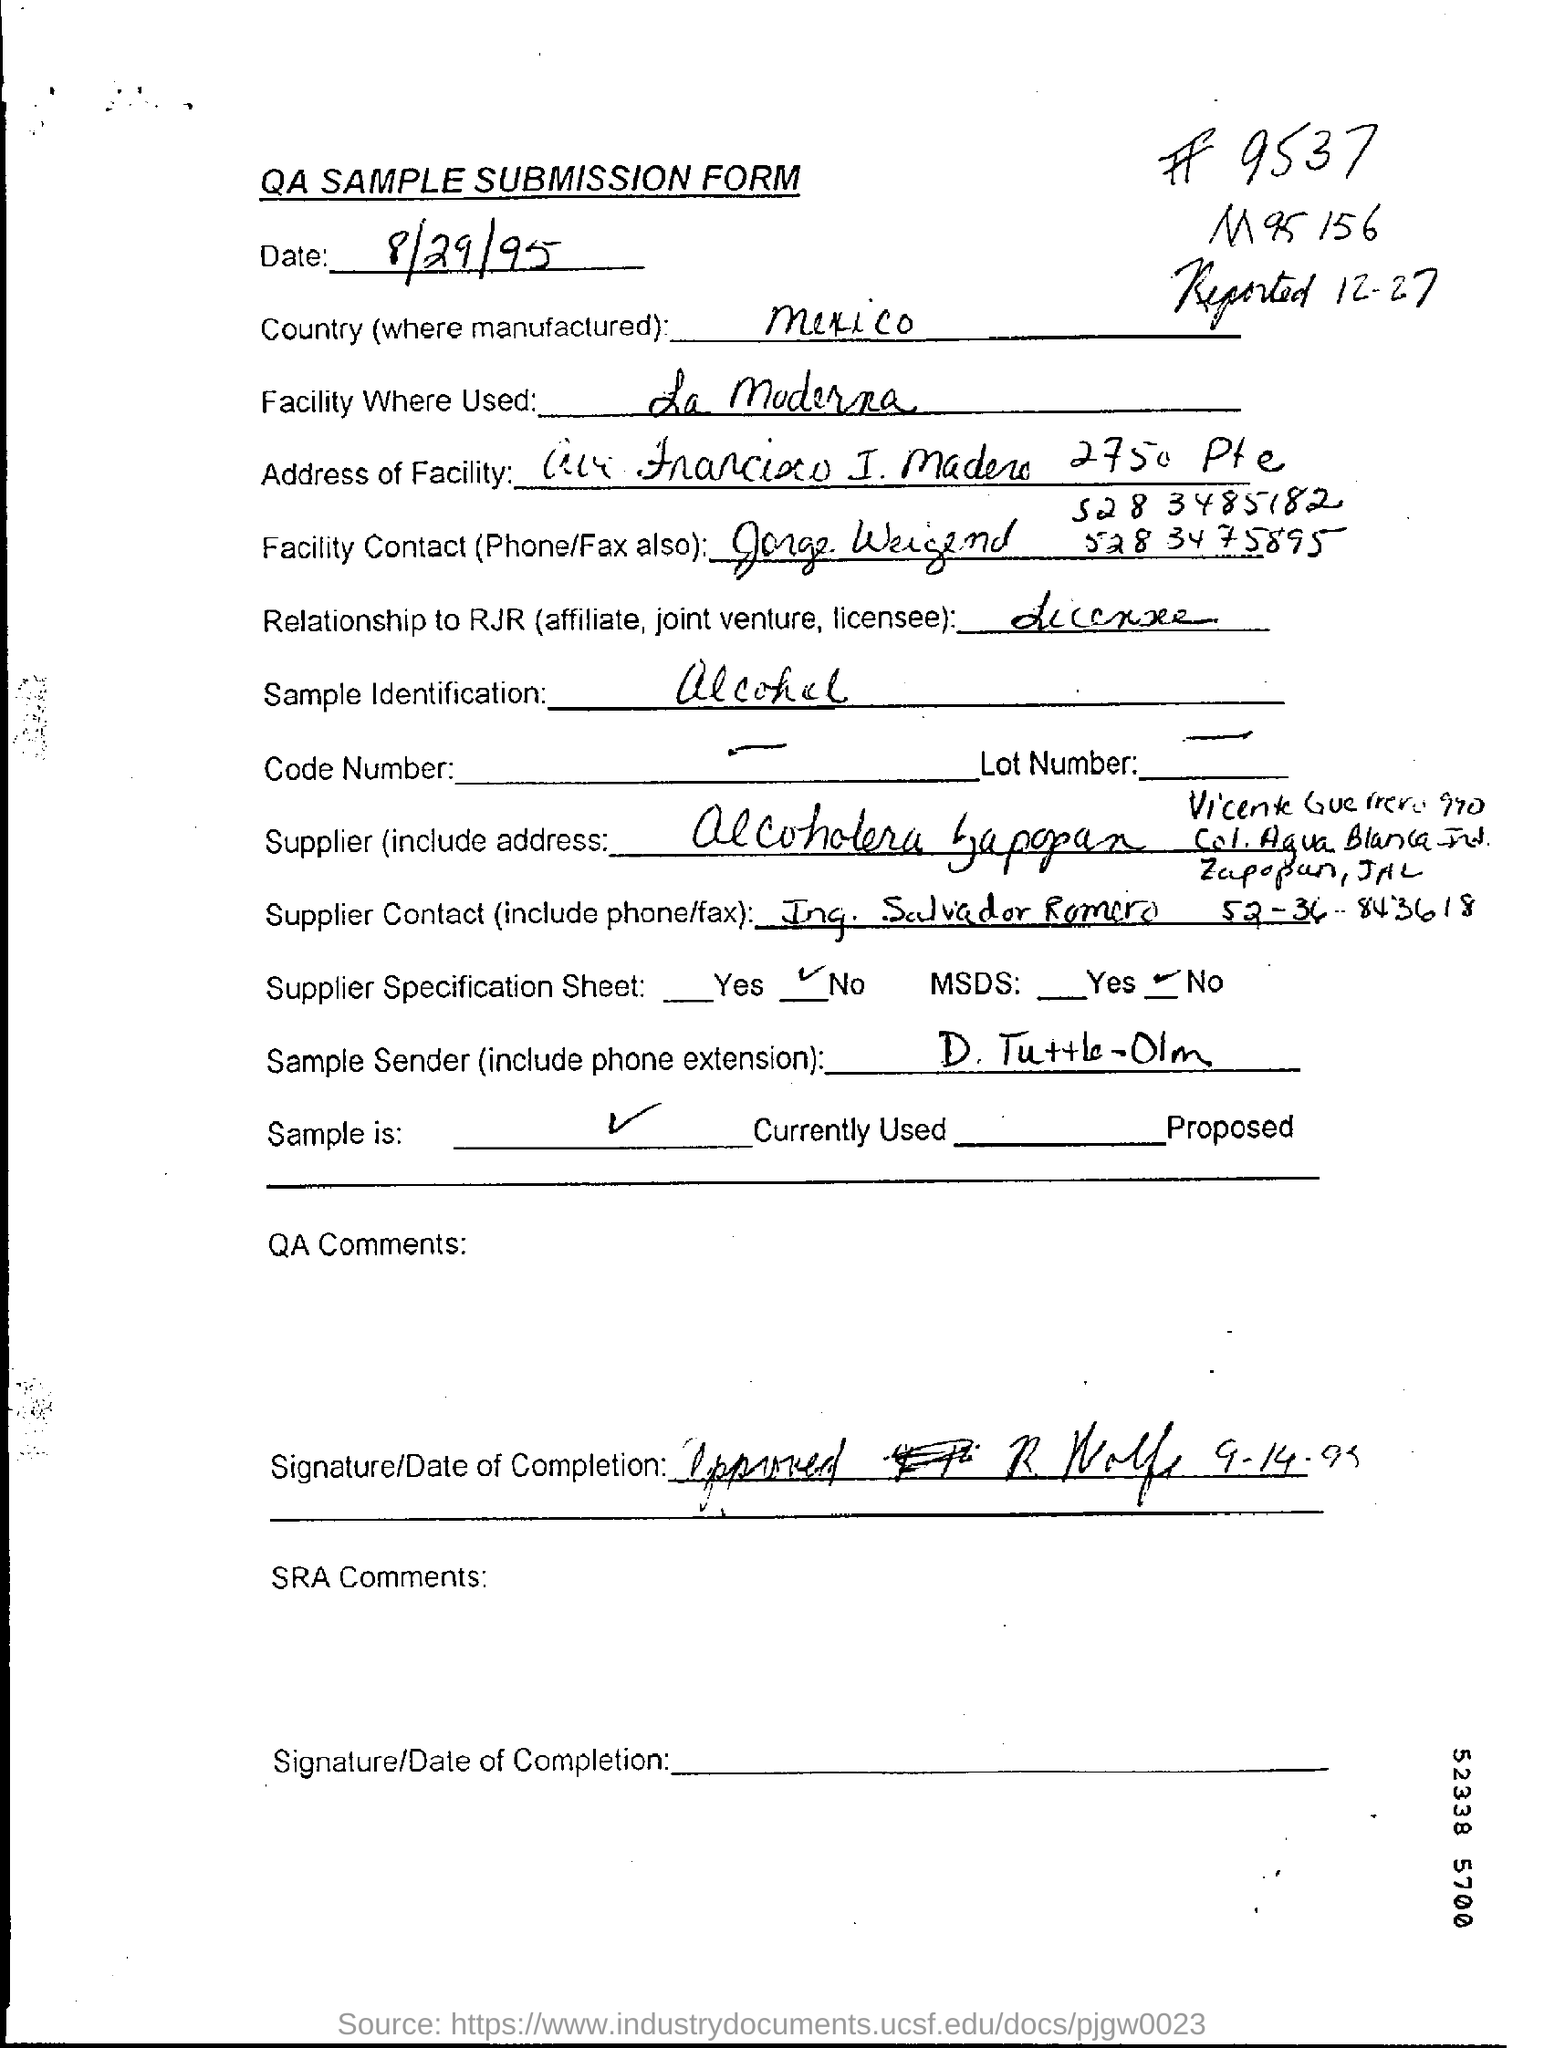In which  country it is manufactured ?
Ensure brevity in your answer.  Mexico. What is the sample identification?
Offer a very short reply. Alcohol. 